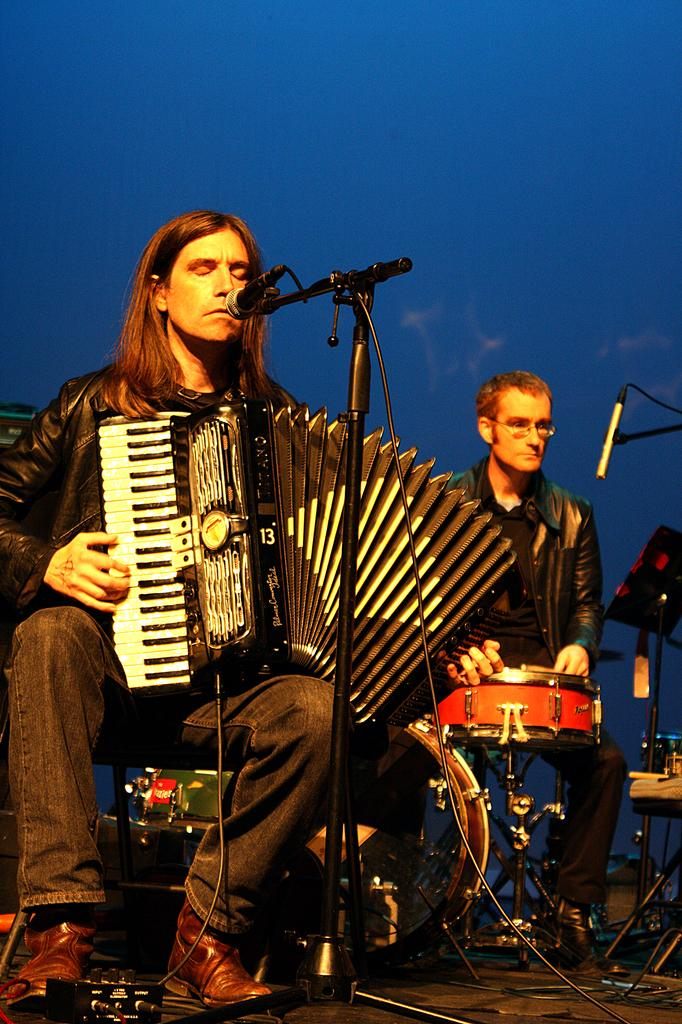How many people are in the image? There are two men in the image. What are the men doing in the image? The men are sitting and playing musical instruments. What objects are in front of the men? There are two microphone stands in front of the men. What can be seen at the top of the image? The sky is visible at the top of the image. What type of love can be seen between the two men in the image? There is no indication of love between the two men in the image; they are simply playing musical instruments. What agreement did the two men reach before starting to play their instruments in the image? There is no information about any agreement between the two men in the image; they are simply playing their instruments. 